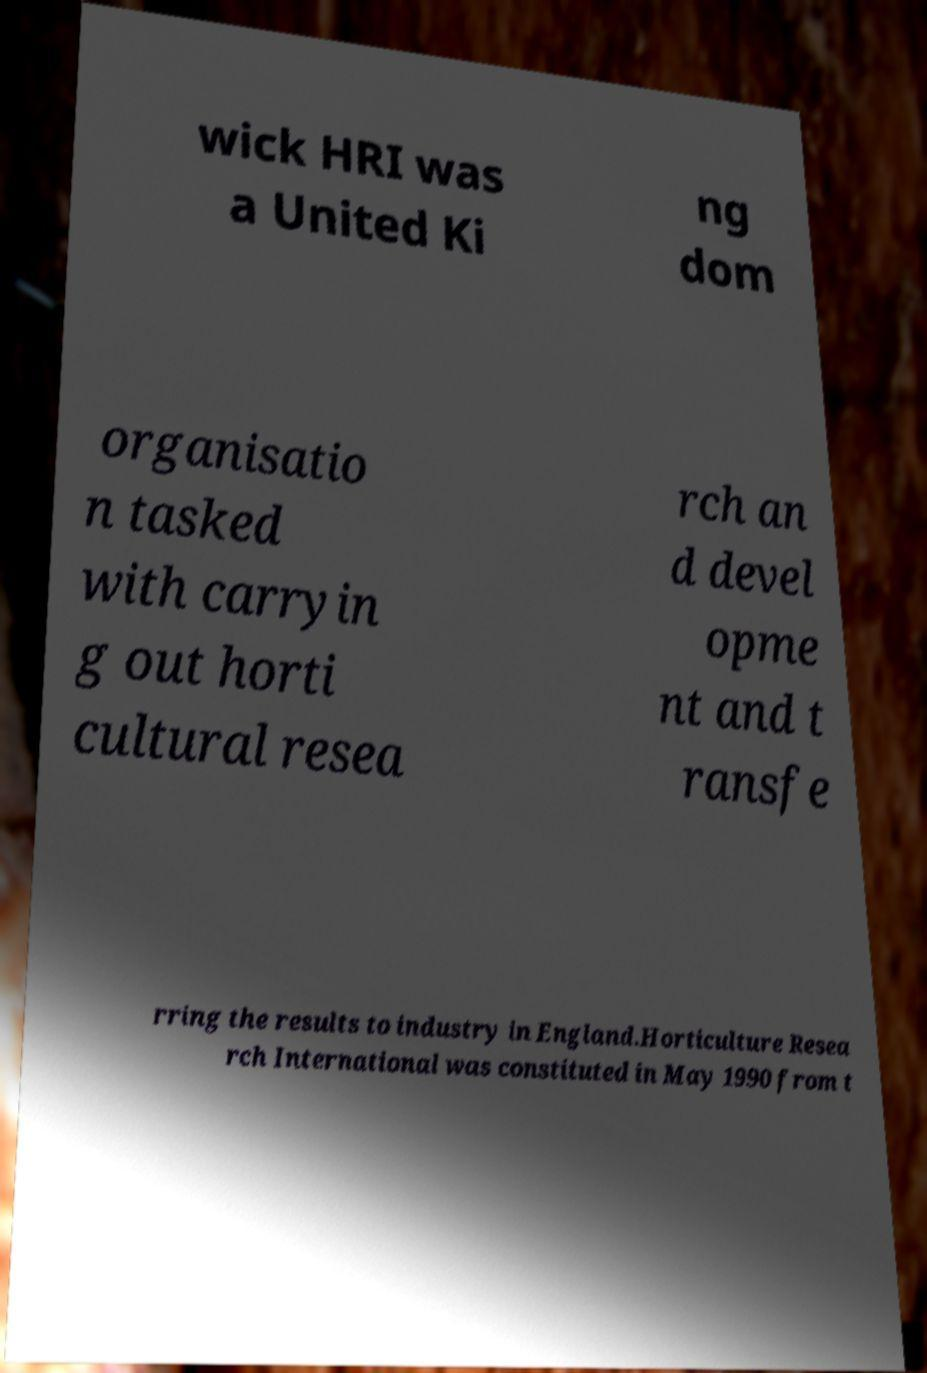Can you read and provide the text displayed in the image?This photo seems to have some interesting text. Can you extract and type it out for me? wick HRI was a United Ki ng dom organisatio n tasked with carryin g out horti cultural resea rch an d devel opme nt and t ransfe rring the results to industry in England.Horticulture Resea rch International was constituted in May 1990 from t 